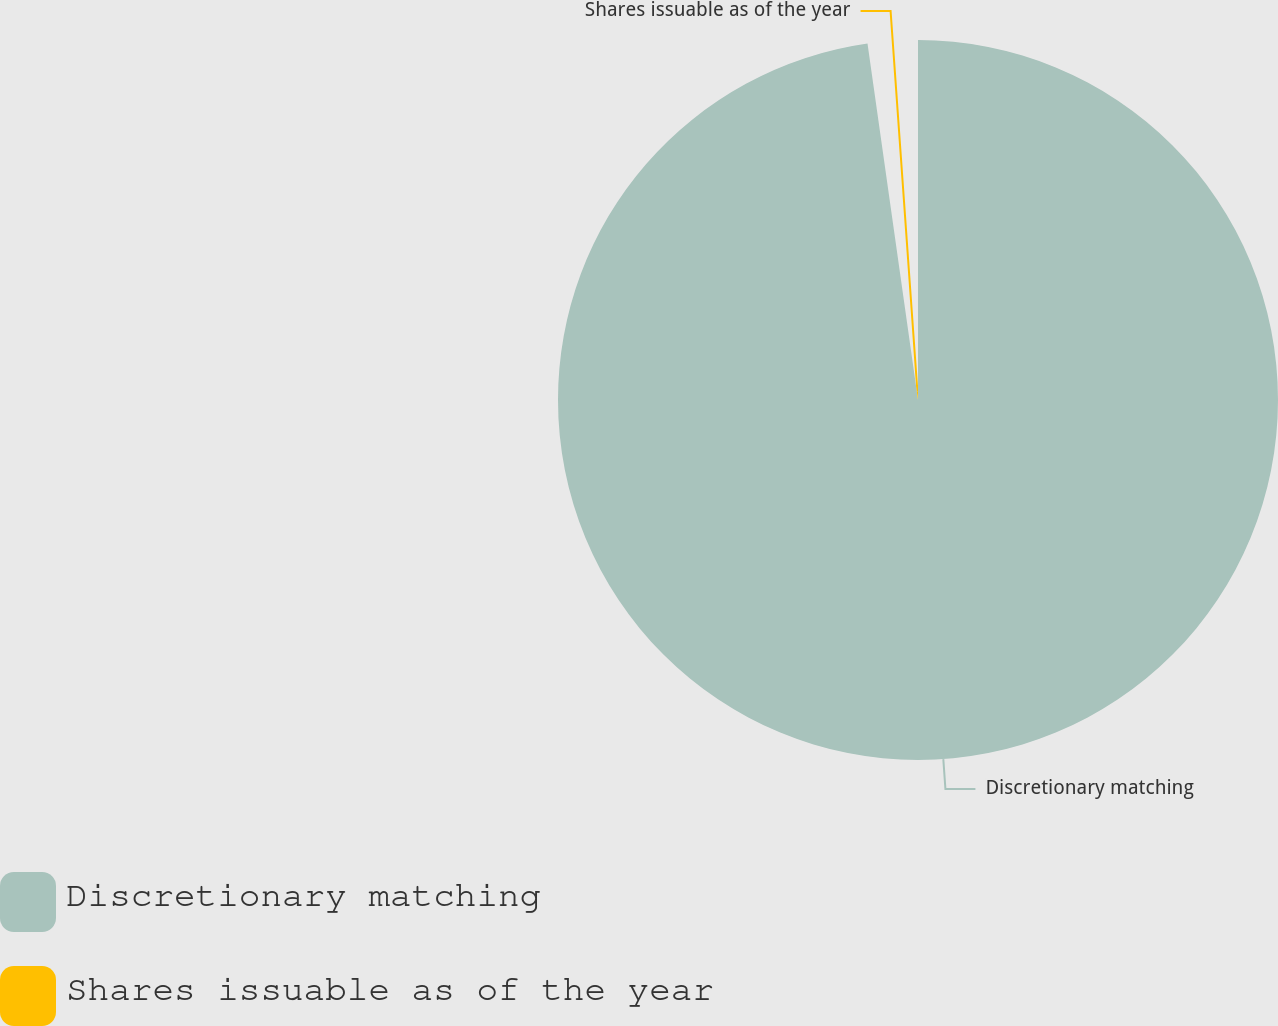Convert chart. <chart><loc_0><loc_0><loc_500><loc_500><pie_chart><fcel>Discretionary matching<fcel>Shares issuable as of the year<nl><fcel>97.76%<fcel>2.24%<nl></chart> 